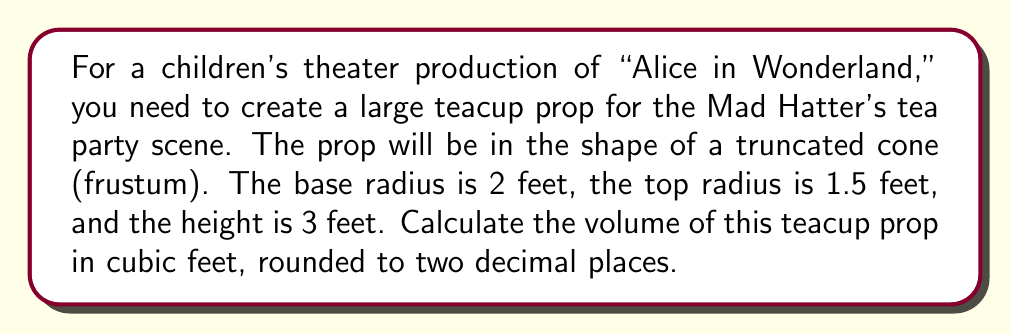Give your solution to this math problem. To solve this problem, we'll use the formula for the volume of a frustum (truncated cone):

$$V = \frac{1}{3}\pi h(R^2 + r^2 + Rr)$$

Where:
$V$ = volume
$h$ = height
$R$ = radius of the base
$r$ = radius of the top

Given:
$h = 3$ feet
$R = 2$ feet
$r = 1.5$ feet

Let's substitute these values into the formula:

$$V = \frac{1}{3}\pi \cdot 3(2^2 + 1.5^2 + 2 \cdot 1.5)$$

Simplifying:
$$V = \pi(4 + 2.25 + 3)$$
$$V = 9.25\pi$$

Using $\pi \approx 3.14159$:

$$V \approx 9.25 \cdot 3.14159$$
$$V \approx 29.05 \text{ cubic feet}$$

Rounding to two decimal places:
$$V \approx 29.05 \text{ cubic feet}$$

This volume represents the capacity of the teacup prop, which is useful for understanding its size and potentially for planning how to fill or decorate it for the stage production.
Answer: $29.05 \text{ cubic feet}$ 